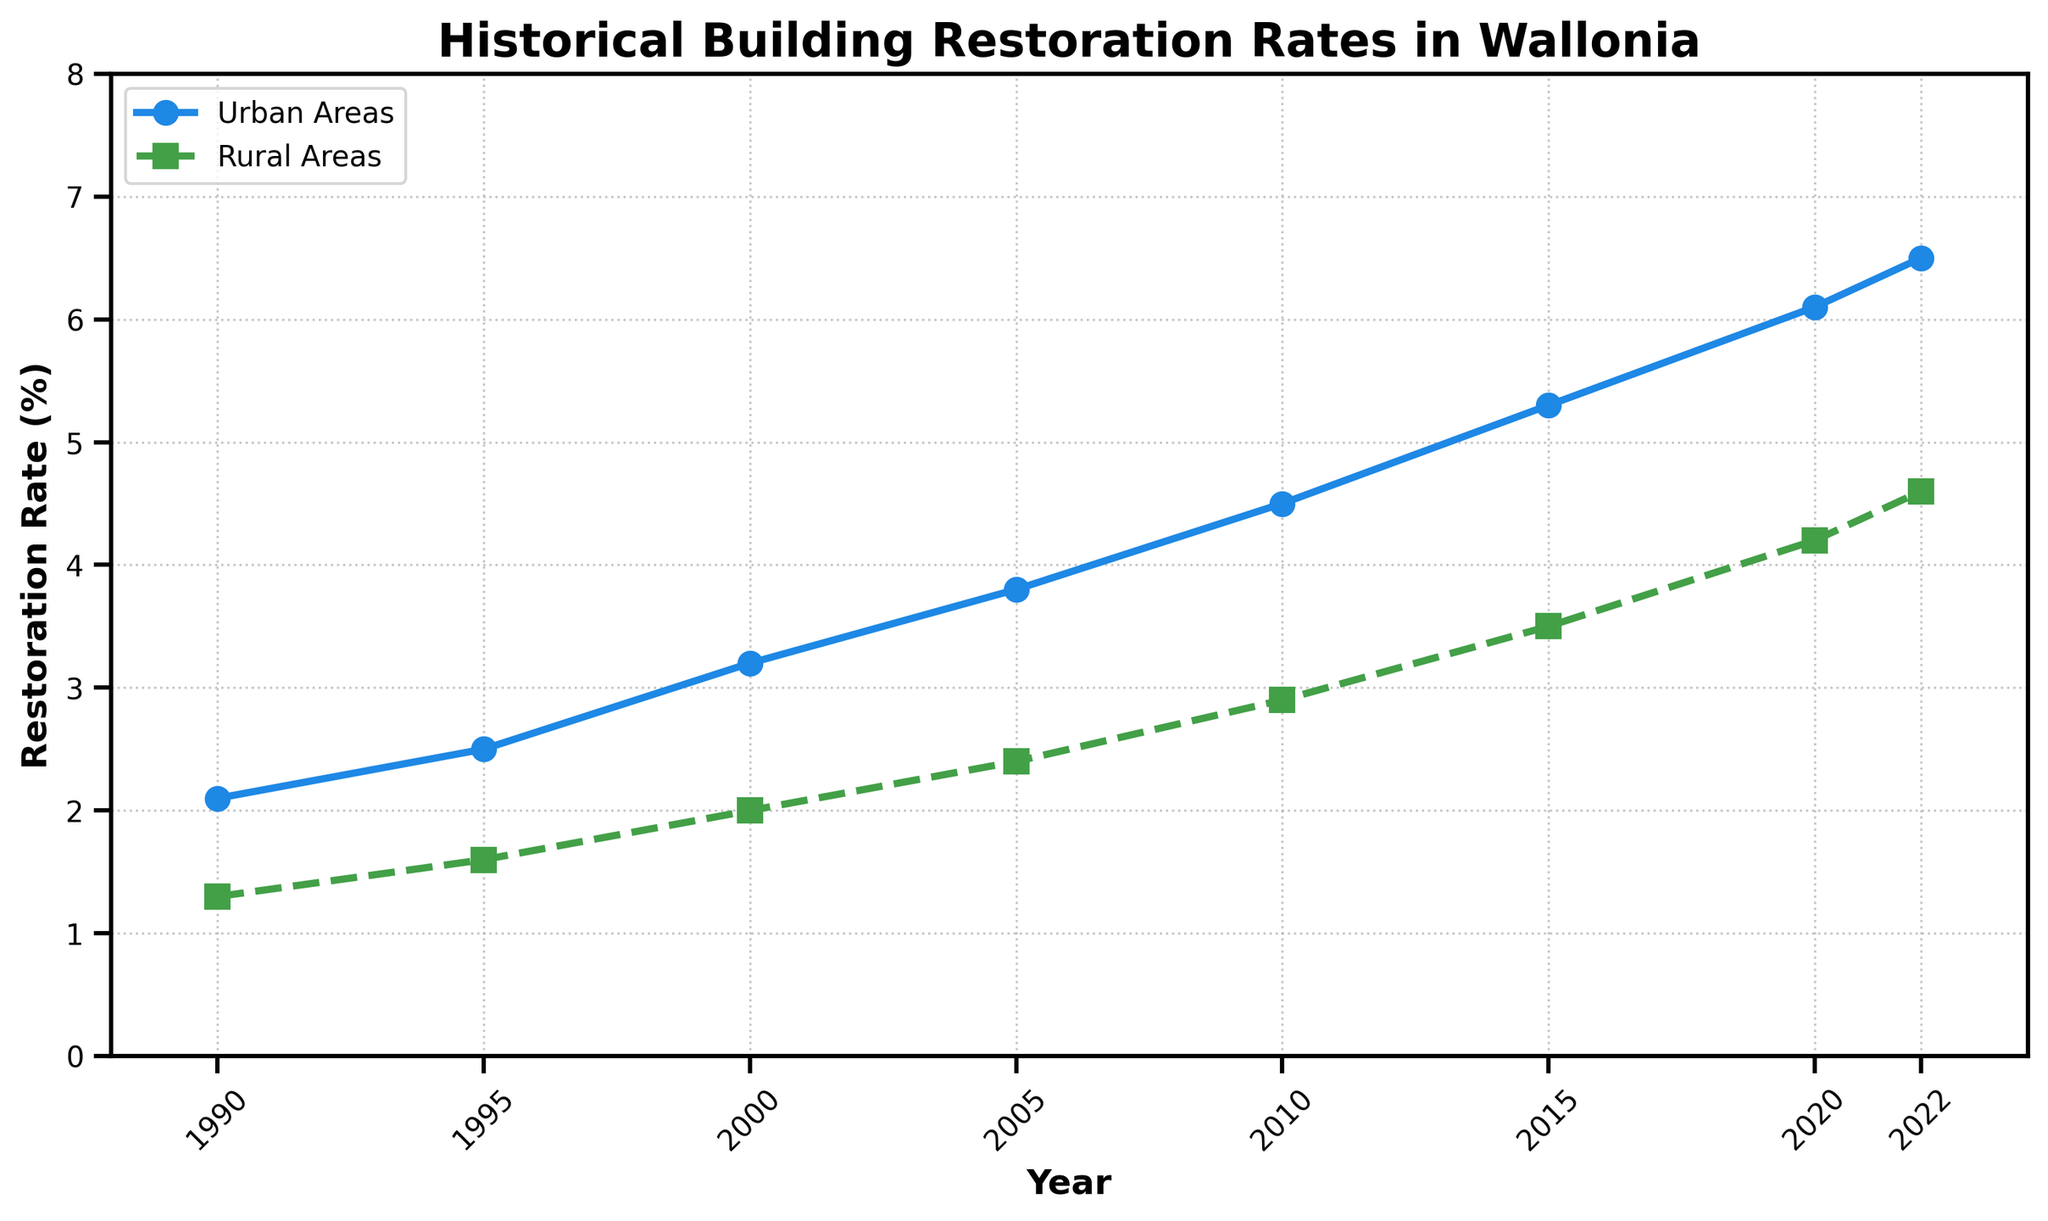What is the difference in the restoration rate between urban and rural areas in 2020? In 2020, the restoration rate for urban areas is 6.1%, and for rural areas, it is 4.2%. The difference is 6.1% - 4.2% = 1.9%.
Answer: 1.9% Which area had a higher restoration rate in 1995, urban or rural? In 1995, the restoration rate for urban areas is 2.5% and for rural areas it is 1.6%. Urban areas had a higher rate.
Answer: Urban areas Has the restoration rate in rural areas ever been greater than the rate in urban areas over the given period? By reviewing the data from 1990 to 2022, the rate of urban areas has always been higher than that of rural areas.
Answer: No What is the average restoration rate for urban areas from 1990 to 2022? The average is calculated by summing the urban rates and dividing by the number of data points: (2.1 + 2.5 + 3.2 + 3.8 + 4.5 + 5.3 + 6.1 + 6.5) / 8 = 34 / 8 = 4.25%.
Answer: 4.25% How much did the restoration rate for rural areas increase from 1990 to 2000? In 1990, the rate for rural areas was 1.3%, and in 2000, it was 2.0%. The increase is 2.0% - 1.3% = 0.7%.
Answer: 0.7% What are the years when the restoration rate in both urban and rural areas saw the highest recorded values? The highest rate for urban areas is 6.5% in 2022, and for rural areas, it is 4.6% in 2022.
Answer: 2022 By how much did the restoration rate in urban areas increase on average every 5 years from 1990 to 2020? The increases are: 2.1 to 2.5 (0.4), 2.5 to 3.2 (0.7), 3.2 to 3.8 (0.6), 3.8 to 4.5 (0.7), 4.5 to 5.3 (0.8), 5.3 to 6.1 (0.8). The average increase every 5 years is (0.4 + 0.7 + 0.6 + 0.7 + 0.8 + 0.8) / 6 = 0.67%.
Answer: 0.67% Compare and identify which years had the most significant increase in restoration rate for urban areas. The increase between each interval can be observed from the data: 1990-1995 (0.4), 1995-2000 (0.7), 2000-2005 (0.6), 2005-2010 (0.7), 2010-2015 (0.8), 2015-2020 (0.8). The most significant increases were in the periods 2010-2015 and 2015-2020, both by 0.8%.
Answer: 2015-2020 and 2010-2015 What is the visual distinction between the lines representing the urban and rural areas on the plot? The urban areas line is represented by a solid line with circular markers, and the rural areas line is represented by a dashed line with square markers. The urban line is blue, and the rural line is green.
Answer: The urban line is solid with circles; the rural line is dashed with squares Determine the trend of restoration rates in rural areas from 1990 to 2022. The restoration rate for rural areas shows a steadily increasing trend from 1.3% in 1990 to 4.6% in 2022.
Answer: Steadily increasing 